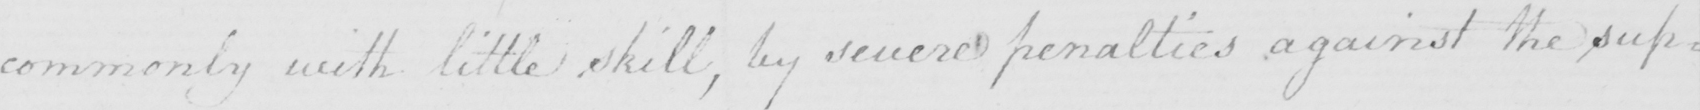What does this handwritten line say? commonly with little skill , by severe penalties against the sup= 